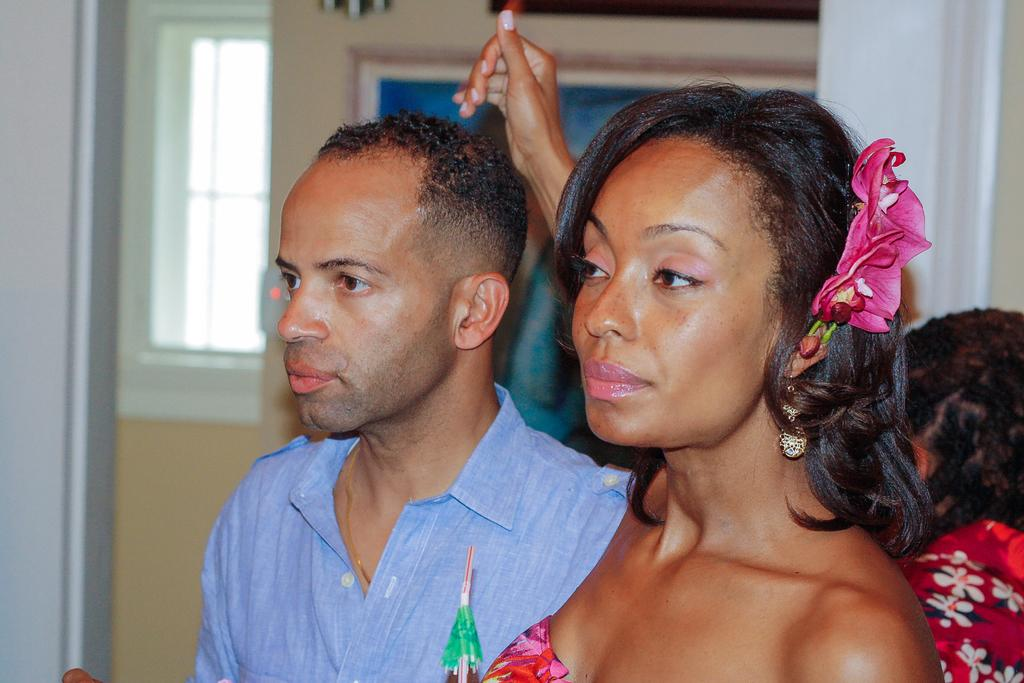How many people are in the foreground of the picture? There are two people, a woman and a man, in the foreground of the picture. Can you describe the person on the right side of the picture? There is a person on the right side of the picture, but their identity or appearance cannot be determined from the provided facts. What is visible in the background of the picture? In the background of the picture, there is a window, a frame, a pillar, and other objects. What architectural feature can be seen in the background of the picture? A pillar can be seen in the background of the picture. What type of fowl can be seen flying through the window in the image? There is no fowl visible in the image, nor is there any indication that a fowl has flown through the window. 